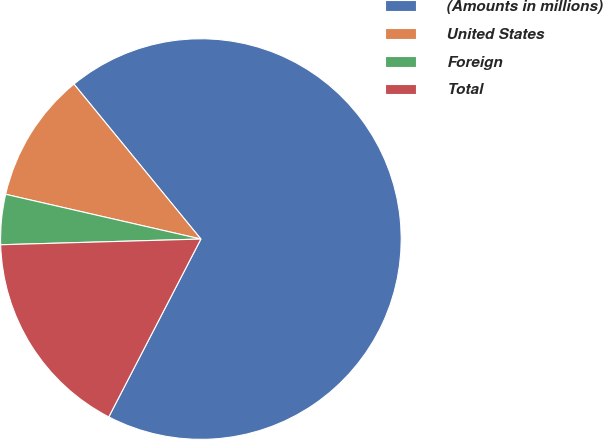<chart> <loc_0><loc_0><loc_500><loc_500><pie_chart><fcel>(Amounts in millions)<fcel>United States<fcel>Foreign<fcel>Total<nl><fcel>68.53%<fcel>10.49%<fcel>4.04%<fcel>16.94%<nl></chart> 